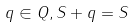Convert formula to latex. <formula><loc_0><loc_0><loc_500><loc_500>q \in Q , S + q = S</formula> 